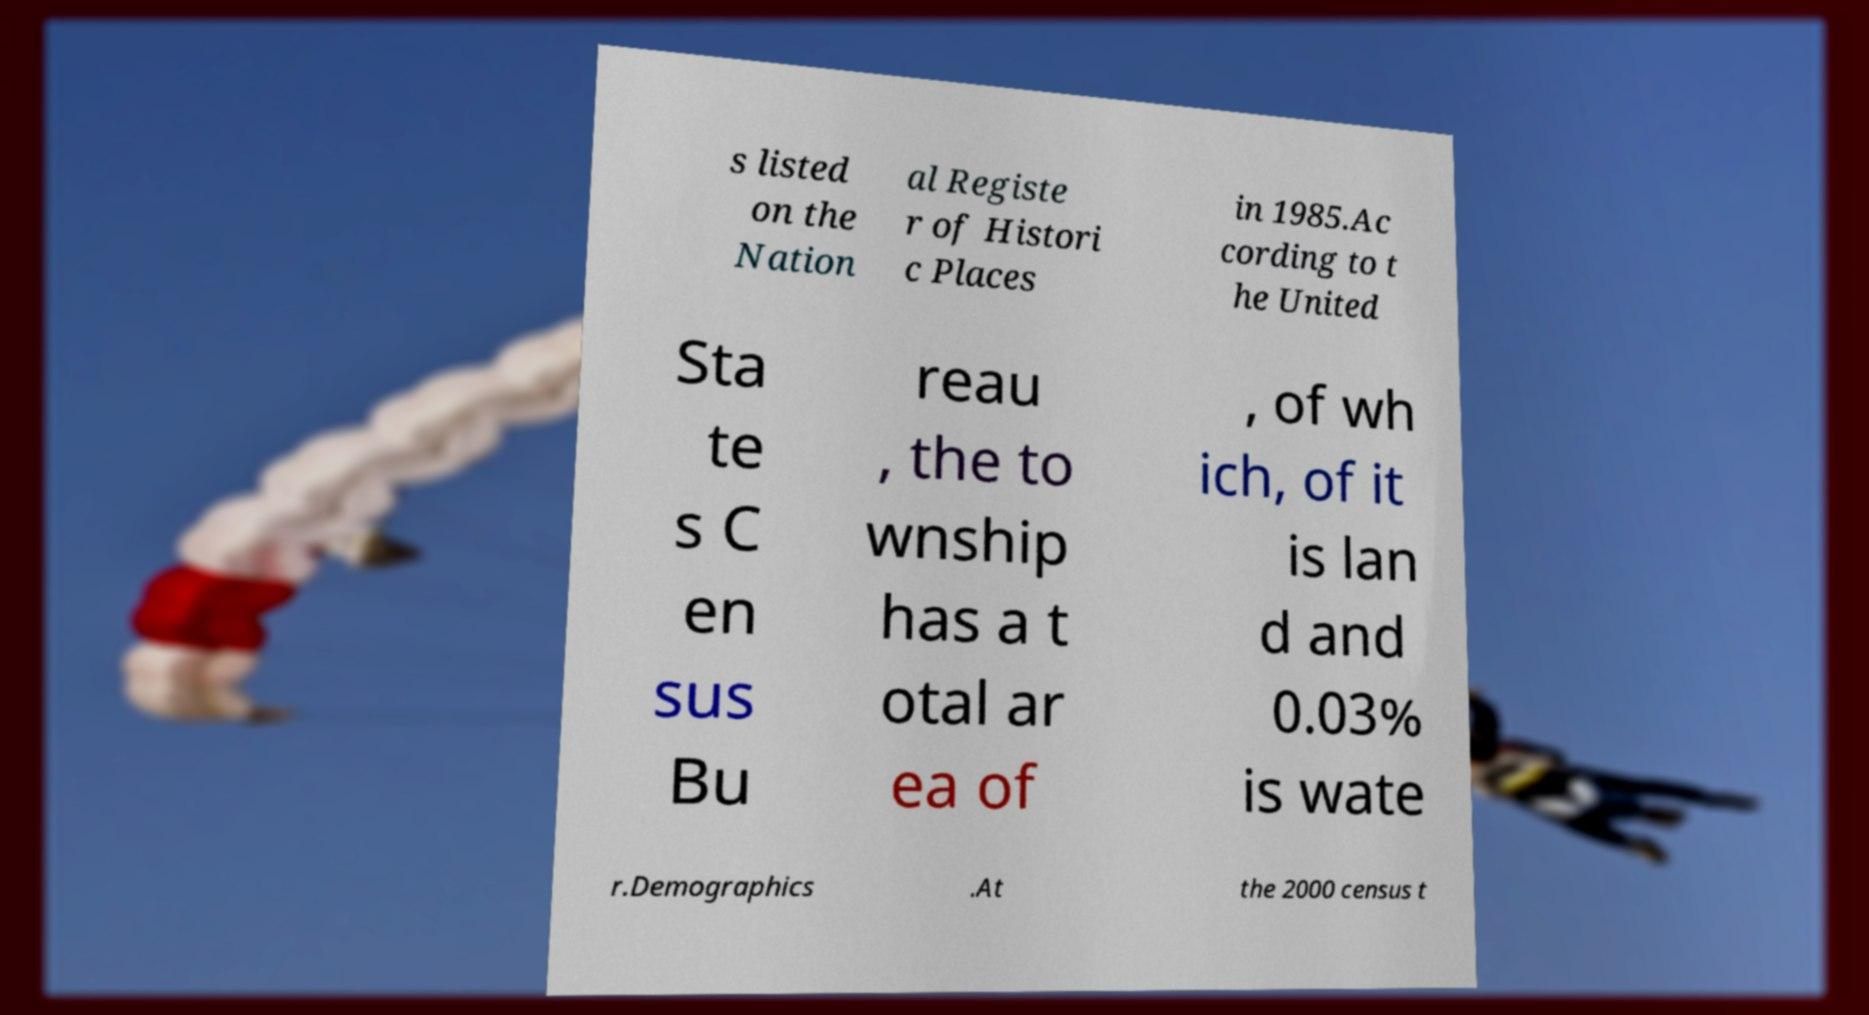There's text embedded in this image that I need extracted. Can you transcribe it verbatim? s listed on the Nation al Registe r of Histori c Places in 1985.Ac cording to t he United Sta te s C en sus Bu reau , the to wnship has a t otal ar ea of , of wh ich, of it is lan d and 0.03% is wate r.Demographics .At the 2000 census t 